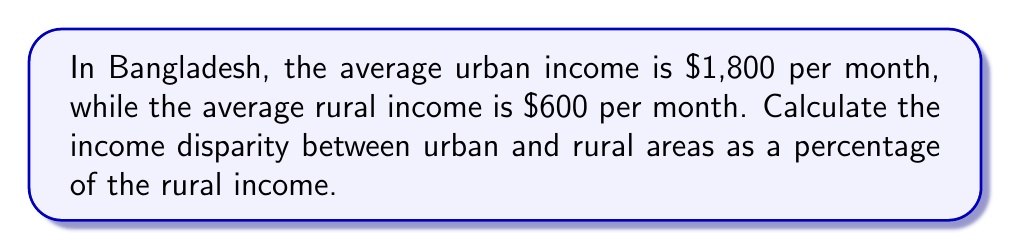Solve this math problem. To solve this problem, we'll follow these steps:

1. Calculate the difference between urban and rural incomes:
   $$ \text{Difference} = \text{Urban Income} - \text{Rural Income} $$
   $$ \text{Difference} = \$1,800 - \$600 = \$1,200 $$

2. Express the difference as a percentage of the rural income:
   $$ \text{Percentage Disparity} = \frac{\text{Difference}}{\text{Rural Income}} \times 100\% $$
   $$ \text{Percentage Disparity} = \frac{\$1,200}{\$600} \times 100\% $$

3. Simplify the fraction:
   $$ \text{Percentage Disparity} = \frac{1200}{600} \times 100\% = 2 \times 100\% = 200\% $$

Therefore, the income disparity between urban and rural areas in Bangladesh is 200% of the rural income.
Answer: 200% 